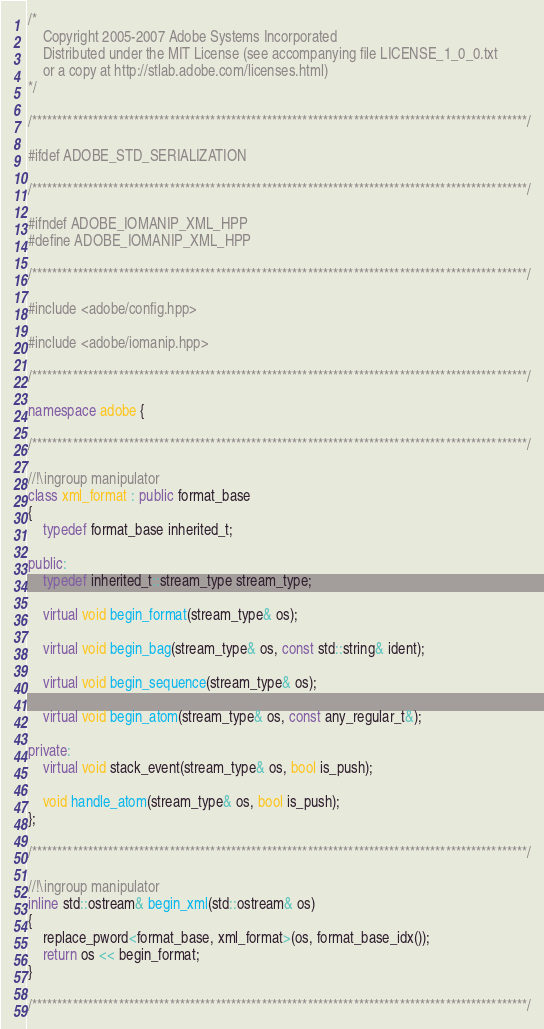<code> <loc_0><loc_0><loc_500><loc_500><_C++_>/*
    Copyright 2005-2007 Adobe Systems Incorporated
    Distributed under the MIT License (see accompanying file LICENSE_1_0_0.txt
    or a copy at http://stlab.adobe.com/licenses.html)
*/

/*************************************************************************************************/

#ifdef ADOBE_STD_SERIALIZATION

/*************************************************************************************************/

#ifndef ADOBE_IOMANIP_XML_HPP
#define ADOBE_IOMANIP_XML_HPP

/*************************************************************************************************/

#include <adobe/config.hpp>

#include <adobe/iomanip.hpp>

/*************************************************************************************************/

namespace adobe {

/*************************************************************************************************/

//!\ingroup manipulator
class xml_format : public format_base
{
    typedef format_base inherited_t;

public:
    typedef inherited_t::stream_type stream_type;

    virtual void begin_format(stream_type& os);

    virtual void begin_bag(stream_type& os, const std::string& ident);

    virtual void begin_sequence(stream_type& os);

    virtual void begin_atom(stream_type& os, const any_regular_t&);

private:
    virtual void stack_event(stream_type& os, bool is_push);

    void handle_atom(stream_type& os, bool is_push);
};

/*************************************************************************************************/

//!\ingroup manipulator
inline std::ostream& begin_xml(std::ostream& os)
{
    replace_pword<format_base, xml_format>(os, format_base_idx());
    return os << begin_format;
}

/*************************************************************************************************/
</code> 